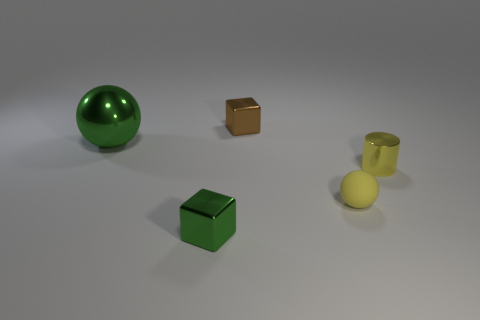Is there anything else that is made of the same material as the tiny yellow ball?
Provide a succinct answer. No. There is a green thing that is the same shape as the tiny brown thing; what size is it?
Make the answer very short. Small. There is a shiny object behind the large thing; what shape is it?
Provide a short and direct response. Cube. Is the tiny block behind the yellow metallic thing made of the same material as the block that is in front of the small matte sphere?
Ensure brevity in your answer.  Yes. There is a yellow matte thing; what shape is it?
Give a very brief answer. Sphere. Are there an equal number of tiny yellow balls in front of the green block and small cyan blocks?
Make the answer very short. Yes. What is the size of the shiny cylinder that is the same color as the small rubber object?
Your answer should be compact. Small. Are there any tiny green blocks that have the same material as the brown thing?
Your response must be concise. Yes. Is the shape of the tiny metallic thing that is in front of the small sphere the same as the metal thing that is behind the large green metal sphere?
Your answer should be compact. Yes. Are any big red blocks visible?
Provide a short and direct response. No. 